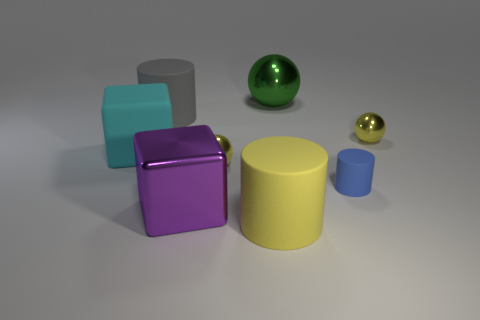Is the number of small blue matte cylinders right of the big gray cylinder less than the number of big purple cubes?
Provide a succinct answer. No. Is there anything else that has the same size as the cyan block?
Your answer should be very brief. Yes. What is the size of the yellow metal object right of the blue matte object behind the big yellow rubber object?
Provide a short and direct response. Small. Is there any other thing that has the same shape as the gray thing?
Provide a short and direct response. Yes. Is the number of large green spheres less than the number of large brown metal cubes?
Your answer should be very brief. No. What material is the large object that is on the right side of the big gray cylinder and behind the tiny blue rubber object?
Provide a succinct answer. Metal. There is a tiny object that is on the left side of the large yellow thing; are there any large rubber cylinders that are right of it?
Make the answer very short. Yes. How many objects are tiny green matte cubes or rubber blocks?
Your answer should be very brief. 1. What is the shape of the big rubber thing that is in front of the big gray object and left of the yellow matte cylinder?
Your answer should be very brief. Cube. Does the big cylinder behind the large yellow cylinder have the same material as the large sphere?
Offer a very short reply. No. 